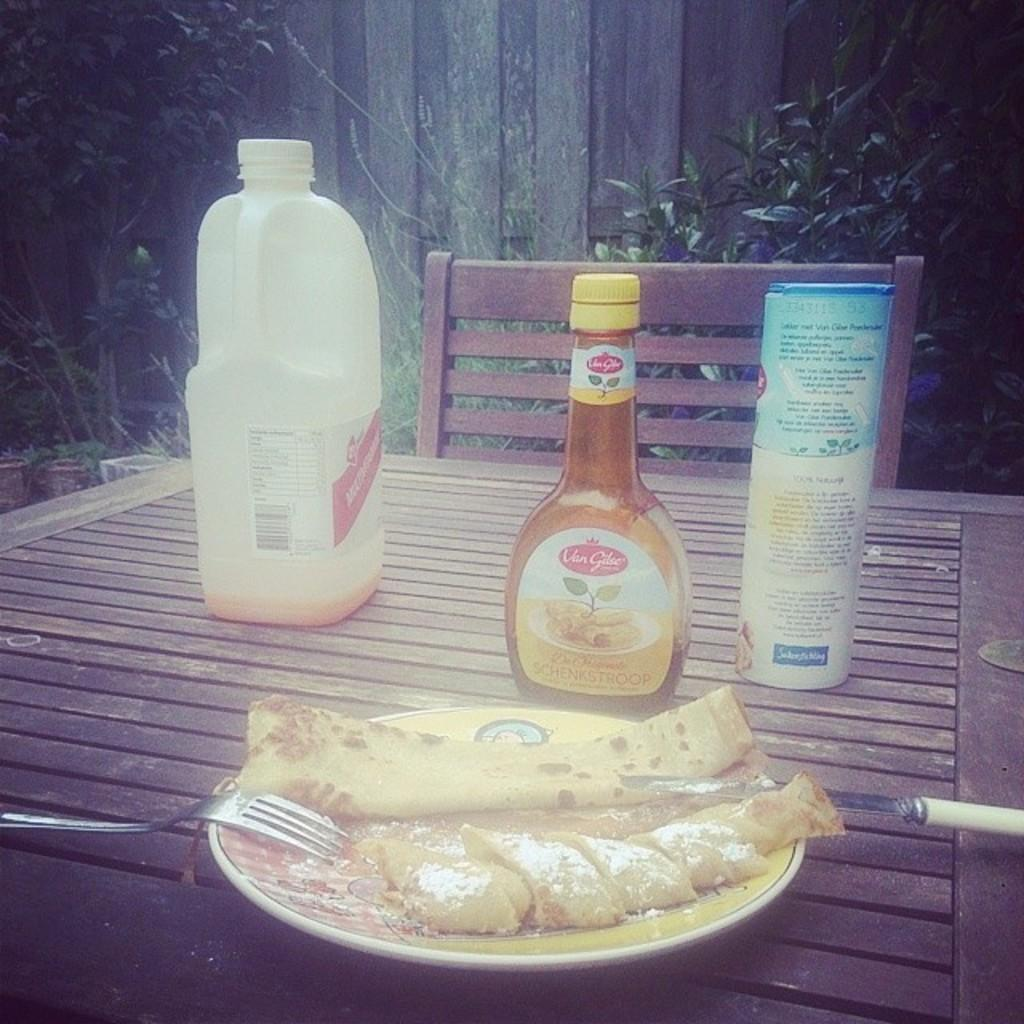What type of furniture is present in the image? There is a chair and a table in the image. What is on the table in the image? The table contains bottles, a plate, a knife, and a fork. Is there any greenery visible in the image? Yes, there is a plant behind the table. What can be inferred about the presence of food in the image? There is food on the table, as indicated by the presence of a plate. What type of sweater is being offered by the chair in the image? There is no sweater present in the image, nor is there any indication of an offer being made. Can you describe the texture of the sand visible in the image? There is no sand visible in the image. 